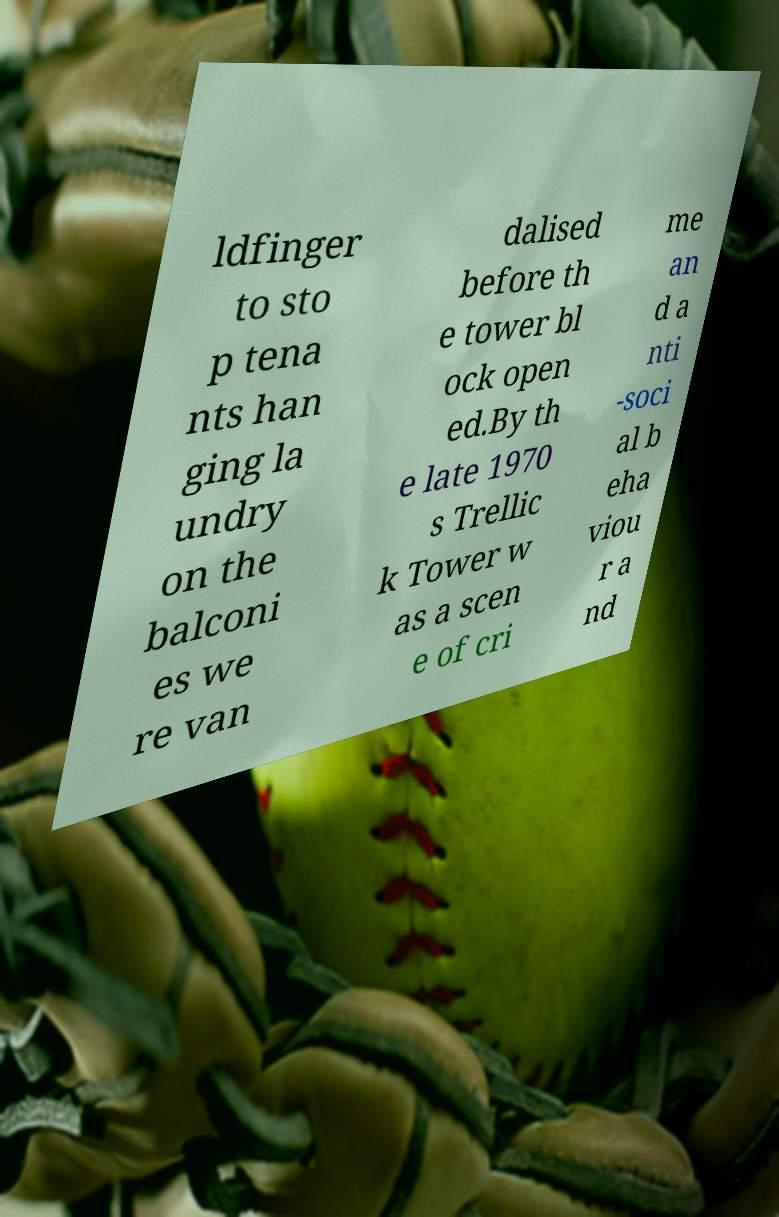For documentation purposes, I need the text within this image transcribed. Could you provide that? ldfinger to sto p tena nts han ging la undry on the balconi es we re van dalised before th e tower bl ock open ed.By th e late 1970 s Trellic k Tower w as a scen e of cri me an d a nti -soci al b eha viou r a nd 